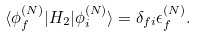Convert formula to latex. <formula><loc_0><loc_0><loc_500><loc_500>\langle \phi _ { f } ^ { ( N ) } | H _ { 2 } | \phi _ { i } ^ { ( N ) } \rangle = \delta _ { f i } \epsilon _ { f } ^ { ( N ) } .</formula> 